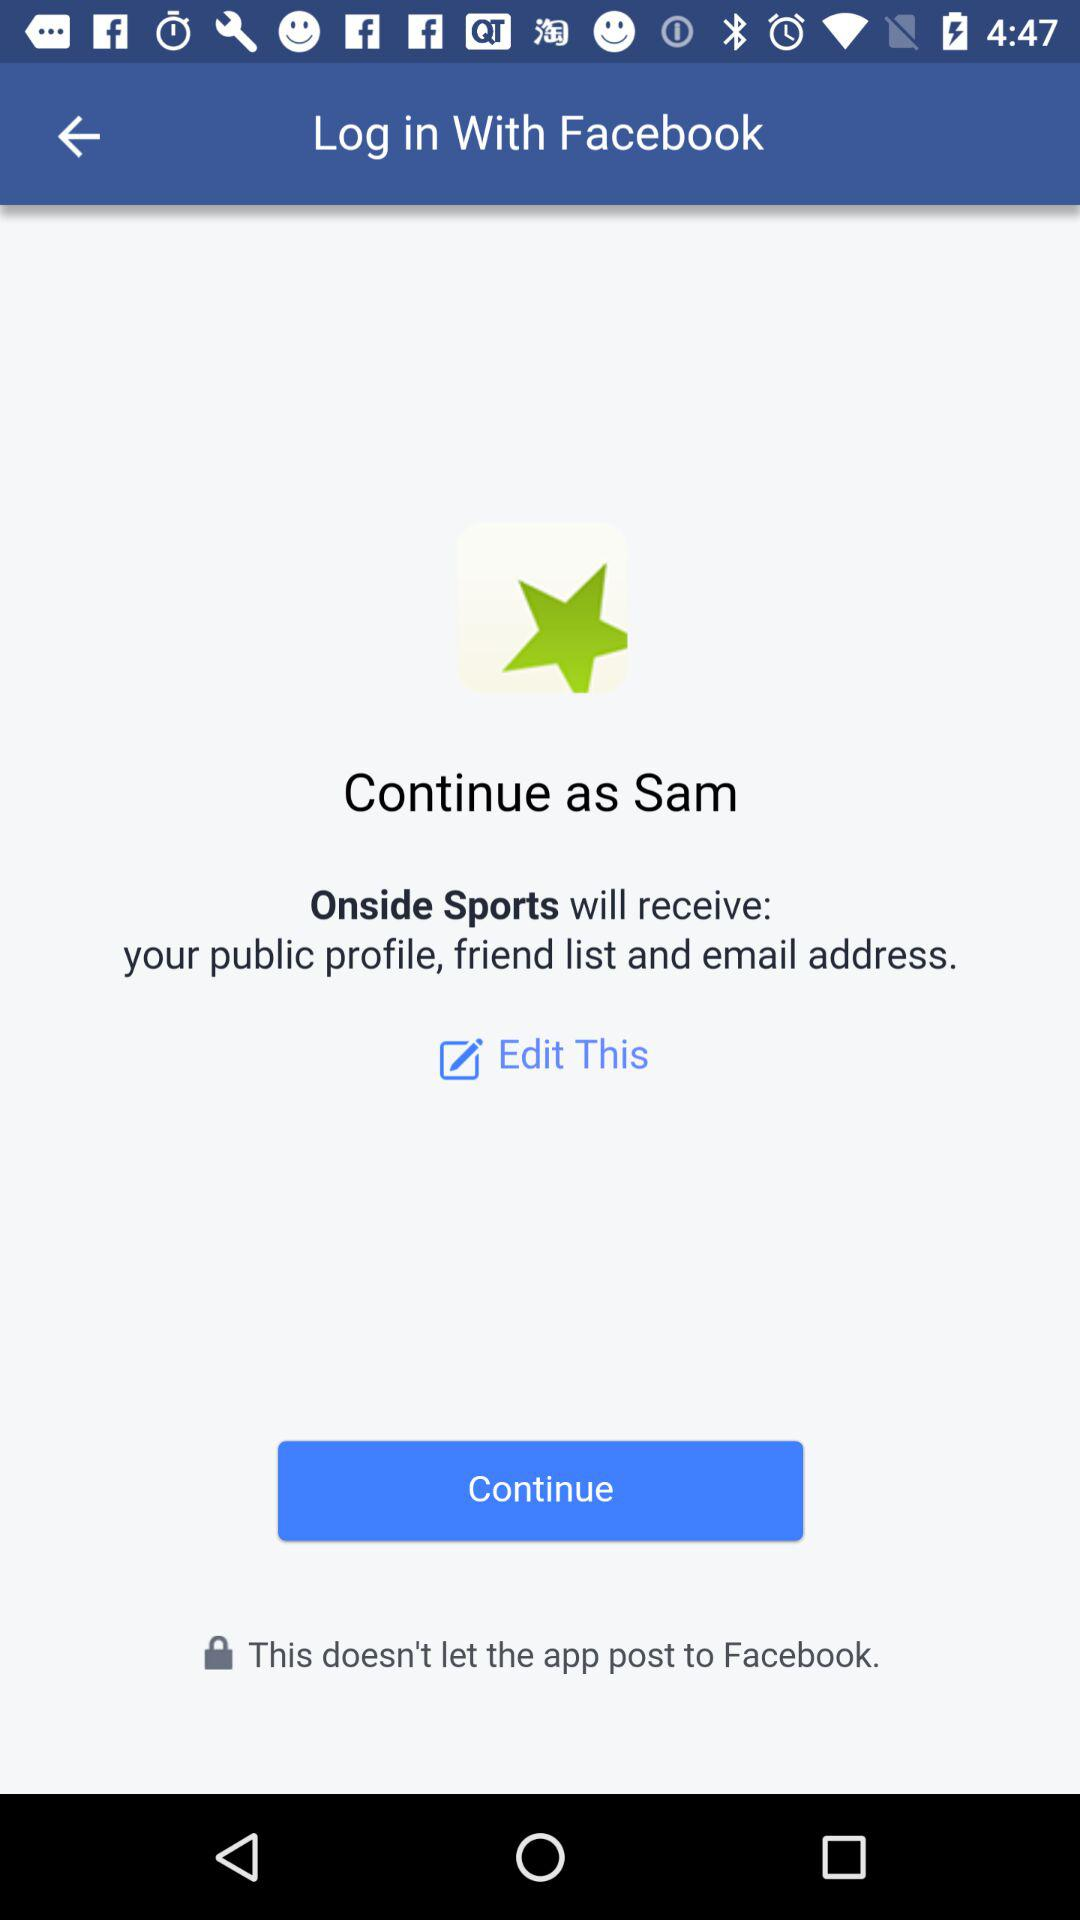What is the user's name? The user's name is Sam. 